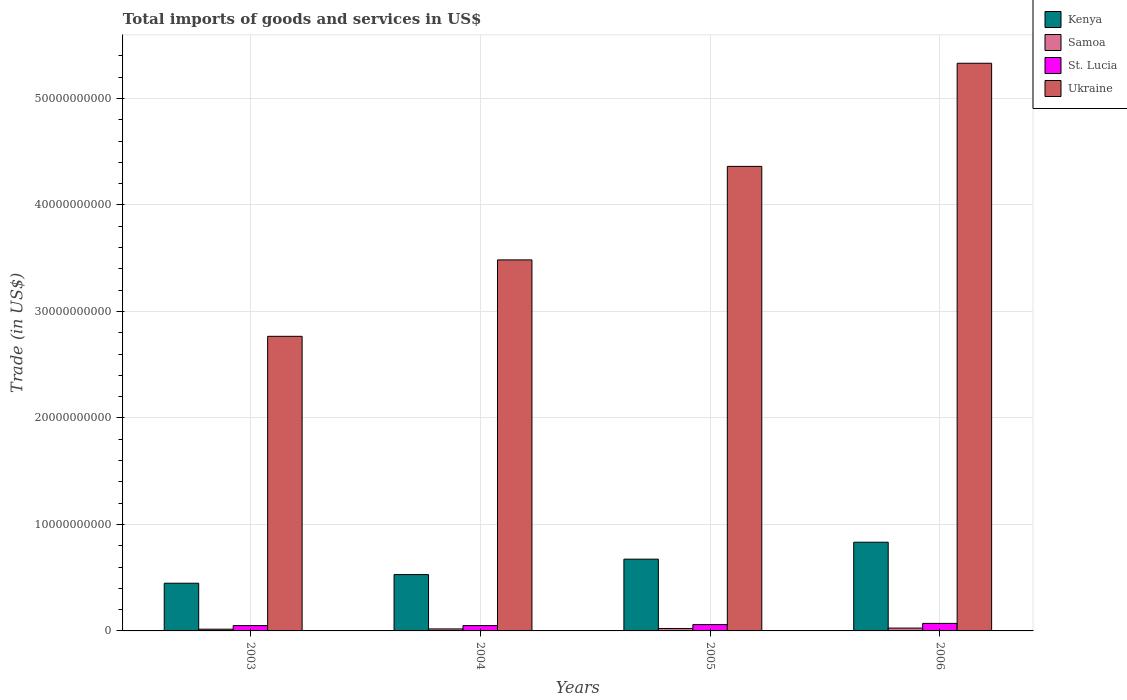How many different coloured bars are there?
Provide a short and direct response. 4. What is the label of the 1st group of bars from the left?
Provide a short and direct response. 2003. What is the total imports of goods and services in Ukraine in 2005?
Provide a succinct answer. 4.36e+1. Across all years, what is the maximum total imports of goods and services in Kenya?
Provide a short and direct response. 8.33e+09. Across all years, what is the minimum total imports of goods and services in Samoa?
Provide a short and direct response. 1.63e+08. What is the total total imports of goods and services in St. Lucia in the graph?
Your response must be concise. 2.30e+09. What is the difference between the total imports of goods and services in Kenya in 2003 and that in 2006?
Your answer should be compact. -3.85e+09. What is the difference between the total imports of goods and services in Kenya in 2003 and the total imports of goods and services in St. Lucia in 2004?
Give a very brief answer. 3.98e+09. What is the average total imports of goods and services in Ukraine per year?
Offer a very short reply. 3.99e+1. In the year 2006, what is the difference between the total imports of goods and services in Ukraine and total imports of goods and services in Kenya?
Give a very brief answer. 4.50e+1. What is the ratio of the total imports of goods and services in St. Lucia in 2003 to that in 2004?
Your answer should be compact. 1. Is the total imports of goods and services in Kenya in 2005 less than that in 2006?
Provide a succinct answer. Yes. What is the difference between the highest and the second highest total imports of goods and services in Ukraine?
Give a very brief answer. 9.68e+09. What is the difference between the highest and the lowest total imports of goods and services in Ukraine?
Keep it short and to the point. 2.56e+1. In how many years, is the total imports of goods and services in Kenya greater than the average total imports of goods and services in Kenya taken over all years?
Ensure brevity in your answer.  2. What does the 1st bar from the left in 2004 represents?
Keep it short and to the point. Kenya. What does the 4th bar from the right in 2005 represents?
Ensure brevity in your answer.  Kenya. Is it the case that in every year, the sum of the total imports of goods and services in St. Lucia and total imports of goods and services in Samoa is greater than the total imports of goods and services in Ukraine?
Offer a terse response. No. Are all the bars in the graph horizontal?
Keep it short and to the point. No. How many years are there in the graph?
Your response must be concise. 4. What is the difference between two consecutive major ticks on the Y-axis?
Provide a short and direct response. 1.00e+1. What is the title of the graph?
Provide a succinct answer. Total imports of goods and services in US$. Does "St. Vincent and the Grenadines" appear as one of the legend labels in the graph?
Provide a succinct answer. No. What is the label or title of the X-axis?
Make the answer very short. Years. What is the label or title of the Y-axis?
Ensure brevity in your answer.  Trade (in US$). What is the Trade (in US$) of Kenya in 2003?
Your answer should be very brief. 4.48e+09. What is the Trade (in US$) in Samoa in 2003?
Your answer should be compact. 1.63e+08. What is the Trade (in US$) in St. Lucia in 2003?
Your response must be concise. 5.00e+08. What is the Trade (in US$) of Ukraine in 2003?
Provide a succinct answer. 2.77e+1. What is the Trade (in US$) of Kenya in 2004?
Keep it short and to the point. 5.29e+09. What is the Trade (in US$) in Samoa in 2004?
Provide a succinct answer. 1.88e+08. What is the Trade (in US$) of St. Lucia in 2004?
Your response must be concise. 5.00e+08. What is the Trade (in US$) in Ukraine in 2004?
Offer a terse response. 3.48e+1. What is the Trade (in US$) in Kenya in 2005?
Offer a very short reply. 6.74e+09. What is the Trade (in US$) of Samoa in 2005?
Provide a succinct answer. 2.30e+08. What is the Trade (in US$) of St. Lucia in 2005?
Offer a terse response. 5.95e+08. What is the Trade (in US$) of Ukraine in 2005?
Give a very brief answer. 4.36e+1. What is the Trade (in US$) of Kenya in 2006?
Ensure brevity in your answer.  8.33e+09. What is the Trade (in US$) in Samoa in 2006?
Your response must be concise. 2.66e+08. What is the Trade (in US$) in St. Lucia in 2006?
Provide a succinct answer. 7.07e+08. What is the Trade (in US$) in Ukraine in 2006?
Provide a succinct answer. 5.33e+1. Across all years, what is the maximum Trade (in US$) in Kenya?
Your response must be concise. 8.33e+09. Across all years, what is the maximum Trade (in US$) of Samoa?
Offer a very short reply. 2.66e+08. Across all years, what is the maximum Trade (in US$) in St. Lucia?
Your response must be concise. 7.07e+08. Across all years, what is the maximum Trade (in US$) of Ukraine?
Provide a succinct answer. 5.33e+1. Across all years, what is the minimum Trade (in US$) in Kenya?
Your answer should be compact. 4.48e+09. Across all years, what is the minimum Trade (in US$) in Samoa?
Give a very brief answer. 1.63e+08. Across all years, what is the minimum Trade (in US$) of St. Lucia?
Give a very brief answer. 5.00e+08. Across all years, what is the minimum Trade (in US$) in Ukraine?
Provide a succinct answer. 2.77e+1. What is the total Trade (in US$) in Kenya in the graph?
Your response must be concise. 2.48e+1. What is the total Trade (in US$) of Samoa in the graph?
Provide a succinct answer. 8.46e+08. What is the total Trade (in US$) in St. Lucia in the graph?
Provide a short and direct response. 2.30e+09. What is the total Trade (in US$) in Ukraine in the graph?
Ensure brevity in your answer.  1.59e+11. What is the difference between the Trade (in US$) of Kenya in 2003 and that in 2004?
Keep it short and to the point. -8.12e+08. What is the difference between the Trade (in US$) of Samoa in 2003 and that in 2004?
Make the answer very short. -2.49e+07. What is the difference between the Trade (in US$) of St. Lucia in 2003 and that in 2004?
Provide a short and direct response. -5.92e+05. What is the difference between the Trade (in US$) in Ukraine in 2003 and that in 2004?
Offer a very short reply. -7.18e+09. What is the difference between the Trade (in US$) of Kenya in 2003 and that in 2005?
Ensure brevity in your answer.  -2.26e+09. What is the difference between the Trade (in US$) of Samoa in 2003 and that in 2005?
Your answer should be very brief. -6.69e+07. What is the difference between the Trade (in US$) of St. Lucia in 2003 and that in 2005?
Ensure brevity in your answer.  -9.51e+07. What is the difference between the Trade (in US$) of Ukraine in 2003 and that in 2005?
Give a very brief answer. -1.60e+1. What is the difference between the Trade (in US$) of Kenya in 2003 and that in 2006?
Keep it short and to the point. -3.85e+09. What is the difference between the Trade (in US$) in Samoa in 2003 and that in 2006?
Offer a very short reply. -1.03e+08. What is the difference between the Trade (in US$) in St. Lucia in 2003 and that in 2006?
Your answer should be compact. -2.07e+08. What is the difference between the Trade (in US$) of Ukraine in 2003 and that in 2006?
Provide a succinct answer. -2.56e+1. What is the difference between the Trade (in US$) in Kenya in 2004 and that in 2005?
Provide a succinct answer. -1.45e+09. What is the difference between the Trade (in US$) of Samoa in 2004 and that in 2005?
Provide a succinct answer. -4.20e+07. What is the difference between the Trade (in US$) in St. Lucia in 2004 and that in 2005?
Give a very brief answer. -9.46e+07. What is the difference between the Trade (in US$) of Ukraine in 2004 and that in 2005?
Your response must be concise. -8.78e+09. What is the difference between the Trade (in US$) of Kenya in 2004 and that in 2006?
Provide a succinct answer. -3.04e+09. What is the difference between the Trade (in US$) in Samoa in 2004 and that in 2006?
Provide a succinct answer. -7.80e+07. What is the difference between the Trade (in US$) in St. Lucia in 2004 and that in 2006?
Your answer should be very brief. -2.06e+08. What is the difference between the Trade (in US$) in Ukraine in 2004 and that in 2006?
Offer a terse response. -1.85e+1. What is the difference between the Trade (in US$) in Kenya in 2005 and that in 2006?
Offer a very short reply. -1.59e+09. What is the difference between the Trade (in US$) of Samoa in 2005 and that in 2006?
Make the answer very short. -3.60e+07. What is the difference between the Trade (in US$) of St. Lucia in 2005 and that in 2006?
Your response must be concise. -1.12e+08. What is the difference between the Trade (in US$) in Ukraine in 2005 and that in 2006?
Your answer should be compact. -9.68e+09. What is the difference between the Trade (in US$) in Kenya in 2003 and the Trade (in US$) in Samoa in 2004?
Give a very brief answer. 4.29e+09. What is the difference between the Trade (in US$) of Kenya in 2003 and the Trade (in US$) of St. Lucia in 2004?
Your answer should be compact. 3.98e+09. What is the difference between the Trade (in US$) in Kenya in 2003 and the Trade (in US$) in Ukraine in 2004?
Your answer should be very brief. -3.04e+1. What is the difference between the Trade (in US$) in Samoa in 2003 and the Trade (in US$) in St. Lucia in 2004?
Ensure brevity in your answer.  -3.37e+08. What is the difference between the Trade (in US$) in Samoa in 2003 and the Trade (in US$) in Ukraine in 2004?
Give a very brief answer. -3.47e+1. What is the difference between the Trade (in US$) of St. Lucia in 2003 and the Trade (in US$) of Ukraine in 2004?
Offer a terse response. -3.43e+1. What is the difference between the Trade (in US$) in Kenya in 2003 and the Trade (in US$) in Samoa in 2005?
Your answer should be very brief. 4.25e+09. What is the difference between the Trade (in US$) in Kenya in 2003 and the Trade (in US$) in St. Lucia in 2005?
Keep it short and to the point. 3.88e+09. What is the difference between the Trade (in US$) in Kenya in 2003 and the Trade (in US$) in Ukraine in 2005?
Give a very brief answer. -3.91e+1. What is the difference between the Trade (in US$) in Samoa in 2003 and the Trade (in US$) in St. Lucia in 2005?
Offer a very short reply. -4.32e+08. What is the difference between the Trade (in US$) of Samoa in 2003 and the Trade (in US$) of Ukraine in 2005?
Your answer should be compact. -4.35e+1. What is the difference between the Trade (in US$) in St. Lucia in 2003 and the Trade (in US$) in Ukraine in 2005?
Give a very brief answer. -4.31e+1. What is the difference between the Trade (in US$) in Kenya in 2003 and the Trade (in US$) in Samoa in 2006?
Ensure brevity in your answer.  4.21e+09. What is the difference between the Trade (in US$) of Kenya in 2003 and the Trade (in US$) of St. Lucia in 2006?
Offer a very short reply. 3.77e+09. What is the difference between the Trade (in US$) of Kenya in 2003 and the Trade (in US$) of Ukraine in 2006?
Provide a short and direct response. -4.88e+1. What is the difference between the Trade (in US$) of Samoa in 2003 and the Trade (in US$) of St. Lucia in 2006?
Keep it short and to the point. -5.44e+08. What is the difference between the Trade (in US$) of Samoa in 2003 and the Trade (in US$) of Ukraine in 2006?
Ensure brevity in your answer.  -5.31e+1. What is the difference between the Trade (in US$) in St. Lucia in 2003 and the Trade (in US$) in Ukraine in 2006?
Give a very brief answer. -5.28e+1. What is the difference between the Trade (in US$) in Kenya in 2004 and the Trade (in US$) in Samoa in 2005?
Give a very brief answer. 5.06e+09. What is the difference between the Trade (in US$) in Kenya in 2004 and the Trade (in US$) in St. Lucia in 2005?
Your answer should be compact. 4.70e+09. What is the difference between the Trade (in US$) of Kenya in 2004 and the Trade (in US$) of Ukraine in 2005?
Make the answer very short. -3.83e+1. What is the difference between the Trade (in US$) in Samoa in 2004 and the Trade (in US$) in St. Lucia in 2005?
Your answer should be very brief. -4.07e+08. What is the difference between the Trade (in US$) in Samoa in 2004 and the Trade (in US$) in Ukraine in 2005?
Give a very brief answer. -4.34e+1. What is the difference between the Trade (in US$) of St. Lucia in 2004 and the Trade (in US$) of Ukraine in 2005?
Make the answer very short. -4.31e+1. What is the difference between the Trade (in US$) in Kenya in 2004 and the Trade (in US$) in Samoa in 2006?
Provide a succinct answer. 5.02e+09. What is the difference between the Trade (in US$) in Kenya in 2004 and the Trade (in US$) in St. Lucia in 2006?
Make the answer very short. 4.58e+09. What is the difference between the Trade (in US$) in Kenya in 2004 and the Trade (in US$) in Ukraine in 2006?
Provide a succinct answer. -4.80e+1. What is the difference between the Trade (in US$) in Samoa in 2004 and the Trade (in US$) in St. Lucia in 2006?
Make the answer very short. -5.19e+08. What is the difference between the Trade (in US$) of Samoa in 2004 and the Trade (in US$) of Ukraine in 2006?
Provide a succinct answer. -5.31e+1. What is the difference between the Trade (in US$) of St. Lucia in 2004 and the Trade (in US$) of Ukraine in 2006?
Ensure brevity in your answer.  -5.28e+1. What is the difference between the Trade (in US$) of Kenya in 2005 and the Trade (in US$) of Samoa in 2006?
Offer a very short reply. 6.47e+09. What is the difference between the Trade (in US$) of Kenya in 2005 and the Trade (in US$) of St. Lucia in 2006?
Your response must be concise. 6.03e+09. What is the difference between the Trade (in US$) of Kenya in 2005 and the Trade (in US$) of Ukraine in 2006?
Give a very brief answer. -4.66e+1. What is the difference between the Trade (in US$) in Samoa in 2005 and the Trade (in US$) in St. Lucia in 2006?
Make the answer very short. -4.77e+08. What is the difference between the Trade (in US$) in Samoa in 2005 and the Trade (in US$) in Ukraine in 2006?
Provide a succinct answer. -5.31e+1. What is the difference between the Trade (in US$) in St. Lucia in 2005 and the Trade (in US$) in Ukraine in 2006?
Your response must be concise. -5.27e+1. What is the average Trade (in US$) in Kenya per year?
Offer a terse response. 6.21e+09. What is the average Trade (in US$) in Samoa per year?
Keep it short and to the point. 2.12e+08. What is the average Trade (in US$) of St. Lucia per year?
Provide a short and direct response. 5.75e+08. What is the average Trade (in US$) of Ukraine per year?
Make the answer very short. 3.99e+1. In the year 2003, what is the difference between the Trade (in US$) of Kenya and Trade (in US$) of Samoa?
Make the answer very short. 4.32e+09. In the year 2003, what is the difference between the Trade (in US$) in Kenya and Trade (in US$) in St. Lucia?
Keep it short and to the point. 3.98e+09. In the year 2003, what is the difference between the Trade (in US$) in Kenya and Trade (in US$) in Ukraine?
Offer a terse response. -2.32e+1. In the year 2003, what is the difference between the Trade (in US$) in Samoa and Trade (in US$) in St. Lucia?
Keep it short and to the point. -3.37e+08. In the year 2003, what is the difference between the Trade (in US$) of Samoa and Trade (in US$) of Ukraine?
Provide a short and direct response. -2.75e+1. In the year 2003, what is the difference between the Trade (in US$) in St. Lucia and Trade (in US$) in Ukraine?
Provide a short and direct response. -2.72e+1. In the year 2004, what is the difference between the Trade (in US$) of Kenya and Trade (in US$) of Samoa?
Your answer should be very brief. 5.10e+09. In the year 2004, what is the difference between the Trade (in US$) of Kenya and Trade (in US$) of St. Lucia?
Your response must be concise. 4.79e+09. In the year 2004, what is the difference between the Trade (in US$) of Kenya and Trade (in US$) of Ukraine?
Offer a very short reply. -2.96e+1. In the year 2004, what is the difference between the Trade (in US$) in Samoa and Trade (in US$) in St. Lucia?
Provide a succinct answer. -3.12e+08. In the year 2004, what is the difference between the Trade (in US$) in Samoa and Trade (in US$) in Ukraine?
Your answer should be compact. -3.47e+1. In the year 2004, what is the difference between the Trade (in US$) in St. Lucia and Trade (in US$) in Ukraine?
Your answer should be compact. -3.43e+1. In the year 2005, what is the difference between the Trade (in US$) in Kenya and Trade (in US$) in Samoa?
Give a very brief answer. 6.51e+09. In the year 2005, what is the difference between the Trade (in US$) of Kenya and Trade (in US$) of St. Lucia?
Offer a terse response. 6.15e+09. In the year 2005, what is the difference between the Trade (in US$) of Kenya and Trade (in US$) of Ukraine?
Provide a short and direct response. -3.69e+1. In the year 2005, what is the difference between the Trade (in US$) in Samoa and Trade (in US$) in St. Lucia?
Provide a short and direct response. -3.65e+08. In the year 2005, what is the difference between the Trade (in US$) of Samoa and Trade (in US$) of Ukraine?
Give a very brief answer. -4.34e+1. In the year 2005, what is the difference between the Trade (in US$) in St. Lucia and Trade (in US$) in Ukraine?
Keep it short and to the point. -4.30e+1. In the year 2006, what is the difference between the Trade (in US$) of Kenya and Trade (in US$) of Samoa?
Offer a terse response. 8.06e+09. In the year 2006, what is the difference between the Trade (in US$) in Kenya and Trade (in US$) in St. Lucia?
Offer a very short reply. 7.62e+09. In the year 2006, what is the difference between the Trade (in US$) of Kenya and Trade (in US$) of Ukraine?
Make the answer very short. -4.50e+1. In the year 2006, what is the difference between the Trade (in US$) in Samoa and Trade (in US$) in St. Lucia?
Give a very brief answer. -4.41e+08. In the year 2006, what is the difference between the Trade (in US$) in Samoa and Trade (in US$) in Ukraine?
Offer a terse response. -5.30e+1. In the year 2006, what is the difference between the Trade (in US$) in St. Lucia and Trade (in US$) in Ukraine?
Ensure brevity in your answer.  -5.26e+1. What is the ratio of the Trade (in US$) of Kenya in 2003 to that in 2004?
Ensure brevity in your answer.  0.85. What is the ratio of the Trade (in US$) of Samoa in 2003 to that in 2004?
Your answer should be compact. 0.87. What is the ratio of the Trade (in US$) of St. Lucia in 2003 to that in 2004?
Make the answer very short. 1. What is the ratio of the Trade (in US$) in Ukraine in 2003 to that in 2004?
Offer a very short reply. 0.79. What is the ratio of the Trade (in US$) of Kenya in 2003 to that in 2005?
Your answer should be very brief. 0.66. What is the ratio of the Trade (in US$) of Samoa in 2003 to that in 2005?
Your answer should be compact. 0.71. What is the ratio of the Trade (in US$) in St. Lucia in 2003 to that in 2005?
Ensure brevity in your answer.  0.84. What is the ratio of the Trade (in US$) of Ukraine in 2003 to that in 2005?
Make the answer very short. 0.63. What is the ratio of the Trade (in US$) of Kenya in 2003 to that in 2006?
Offer a very short reply. 0.54. What is the ratio of the Trade (in US$) of Samoa in 2003 to that in 2006?
Ensure brevity in your answer.  0.61. What is the ratio of the Trade (in US$) of St. Lucia in 2003 to that in 2006?
Provide a short and direct response. 0.71. What is the ratio of the Trade (in US$) of Ukraine in 2003 to that in 2006?
Your response must be concise. 0.52. What is the ratio of the Trade (in US$) in Kenya in 2004 to that in 2005?
Keep it short and to the point. 0.78. What is the ratio of the Trade (in US$) in Samoa in 2004 to that in 2005?
Give a very brief answer. 0.82. What is the ratio of the Trade (in US$) of St. Lucia in 2004 to that in 2005?
Provide a succinct answer. 0.84. What is the ratio of the Trade (in US$) in Ukraine in 2004 to that in 2005?
Give a very brief answer. 0.8. What is the ratio of the Trade (in US$) of Kenya in 2004 to that in 2006?
Offer a very short reply. 0.64. What is the ratio of the Trade (in US$) in Samoa in 2004 to that in 2006?
Your answer should be very brief. 0.71. What is the ratio of the Trade (in US$) in St. Lucia in 2004 to that in 2006?
Provide a succinct answer. 0.71. What is the ratio of the Trade (in US$) in Ukraine in 2004 to that in 2006?
Give a very brief answer. 0.65. What is the ratio of the Trade (in US$) in Kenya in 2005 to that in 2006?
Ensure brevity in your answer.  0.81. What is the ratio of the Trade (in US$) in Samoa in 2005 to that in 2006?
Your answer should be compact. 0.86. What is the ratio of the Trade (in US$) in St. Lucia in 2005 to that in 2006?
Offer a terse response. 0.84. What is the ratio of the Trade (in US$) in Ukraine in 2005 to that in 2006?
Provide a short and direct response. 0.82. What is the difference between the highest and the second highest Trade (in US$) in Kenya?
Offer a terse response. 1.59e+09. What is the difference between the highest and the second highest Trade (in US$) of Samoa?
Your answer should be very brief. 3.60e+07. What is the difference between the highest and the second highest Trade (in US$) in St. Lucia?
Give a very brief answer. 1.12e+08. What is the difference between the highest and the second highest Trade (in US$) of Ukraine?
Offer a very short reply. 9.68e+09. What is the difference between the highest and the lowest Trade (in US$) of Kenya?
Give a very brief answer. 3.85e+09. What is the difference between the highest and the lowest Trade (in US$) in Samoa?
Your response must be concise. 1.03e+08. What is the difference between the highest and the lowest Trade (in US$) in St. Lucia?
Provide a succinct answer. 2.07e+08. What is the difference between the highest and the lowest Trade (in US$) of Ukraine?
Offer a very short reply. 2.56e+1. 